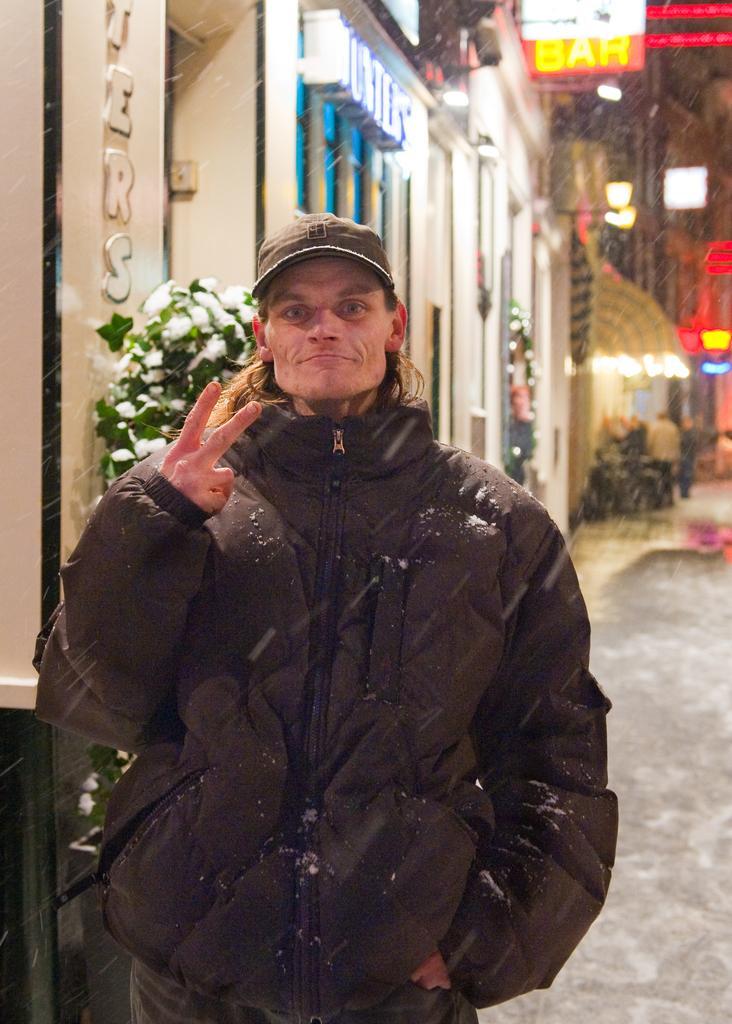Could you give a brief overview of what you see in this image? In the image we can see there is a man standing and he is wearing jacket and cap. Behind there are buildings. 